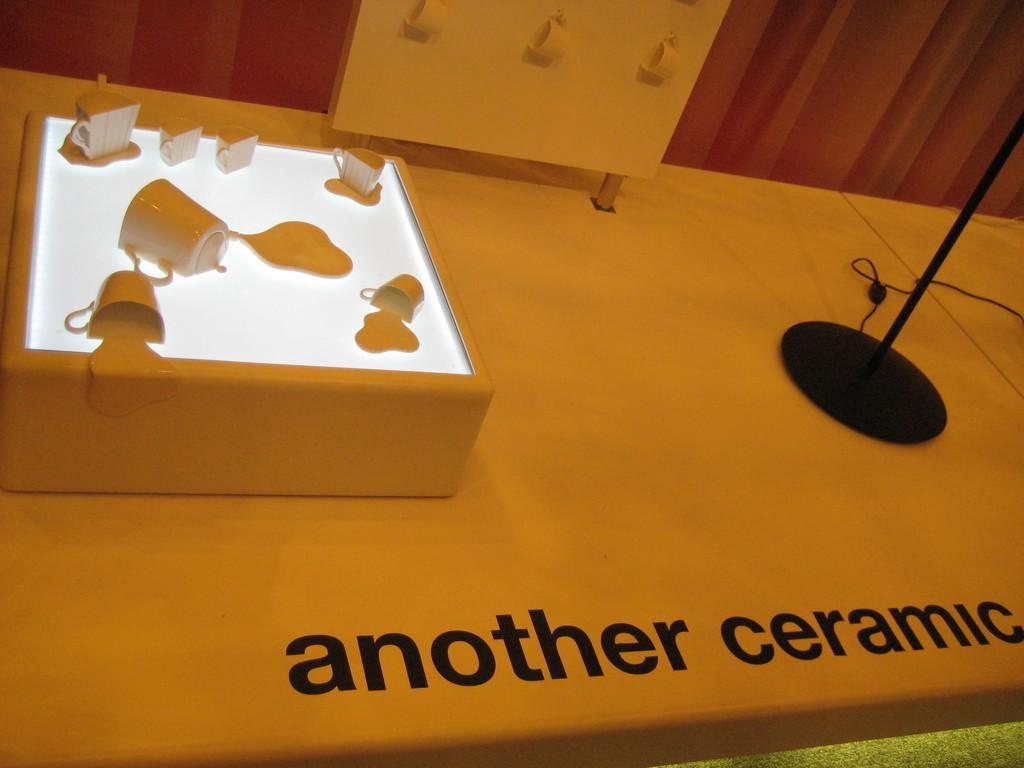<image>
Offer a succinct explanation of the picture presented. Another ceramic brand ceramic statement pieces on a table. 